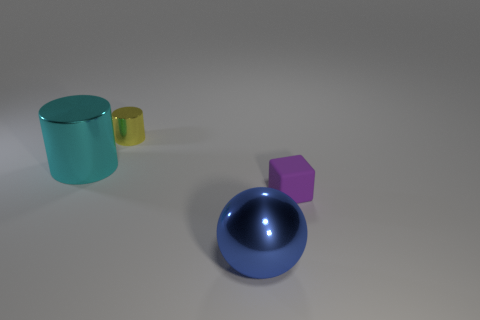Add 2 small red metallic blocks. How many objects exist? 6 Add 4 blue metallic balls. How many blue metallic balls are left? 5 Add 1 big blue metal balls. How many big blue metal balls exist? 2 Subtract 0 brown blocks. How many objects are left? 4 Subtract all large cyan cylinders. Subtract all rubber cubes. How many objects are left? 2 